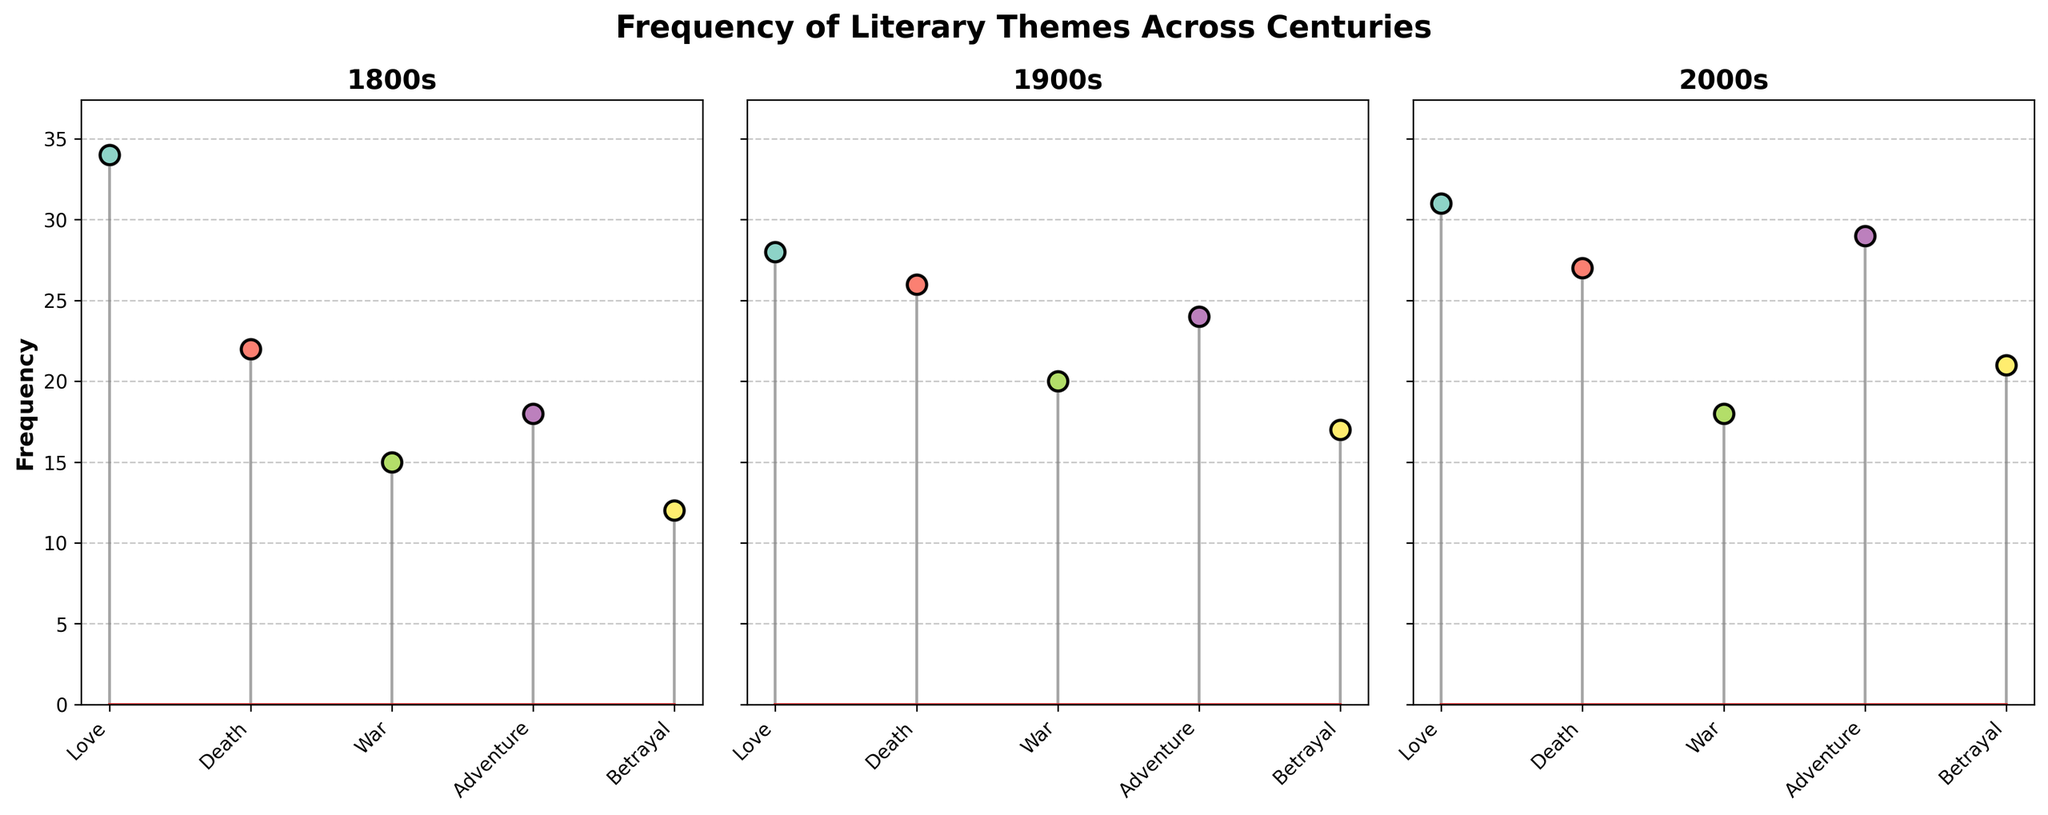What's the title of the figure? The title is typically located at the top center of a plot. In this case, the figure's title is "Frequency of Literary Themes Across Centuries".
Answer: Frequency of Literary Themes Across Centuries Which century has the highest frequency of the theme "Love"? By looking at the 'Love' theme across the subplots for each century, identify the highest bar: For the 1800s (34), 1900s (28), and 2000s (31). The highest value is in the 1800s.
Answer: 1800s What is the average frequency of the theme "Adventure" across all centuries? Calculate the average of the 'Adventure' theme values: (1800s: 18, 1900s: 24, 2000s: 29). The sum is 71, and there are 3 centuries. 71/3 = 23.67
Answer: 23.67 Which theme has the lowest frequency in the 1900s? Examine the frequencies for the 1900s subplot and identify the lowest value: Love (28), Death (26), War (20), Adventure (24), Betrayal (17). The lowest is Betrayal (17).
Answer: Betrayal How does the frequency of the theme "War" in the 2000s compare to that in the 1800s? Compare the 'War' theme values between the 2000s (18) and the 1800s (15). Since 18 is greater than 15, the theme is more frequent in the 2000s.
Answer: More frequent in the 2000s What's the difference in frequency of the theme "Death" between the 1800s and 1900s? Subtract the 'Death' theme frequency in 1800s (22) from the frequency in the 1900s (26). 26 - 22 = 4
Answer: 4 Which century has more balanced theme frequencies? Compare variability across centuries by observing each subplot. The 1900s plot has smaller differences between the highest and lowest frequencies (28-17=11) compared to 1800s (34-12=22) and 2000s (31-18=13), indicating a more balanced distribution.
Answer: 1900s What is the total frequency of the theme "Betrayal" across all centuries? Sum the 'Betrayal' theme frequencies for the 1800s (12), 1900s (17), and 2000s (21). The total is 12 + 17 + 21 = 50.
Answer: 50 How many themes are there in this figure? Count the number of unique themes listed along the x-axis for each subplot. There are five: Love, Death, War, Adventure, Betrayal.
Answer: 5 Which century shows the highest overall frequency across all themes? Sum the frequencies of all themes for each century and identify the highest: 1800s (34+22+15+18+12=101), 1900s (28+26+20+24+17=115), 2000s (31+27+18+29+21=126). The highest total is for the 2000s.
Answer: 2000s 